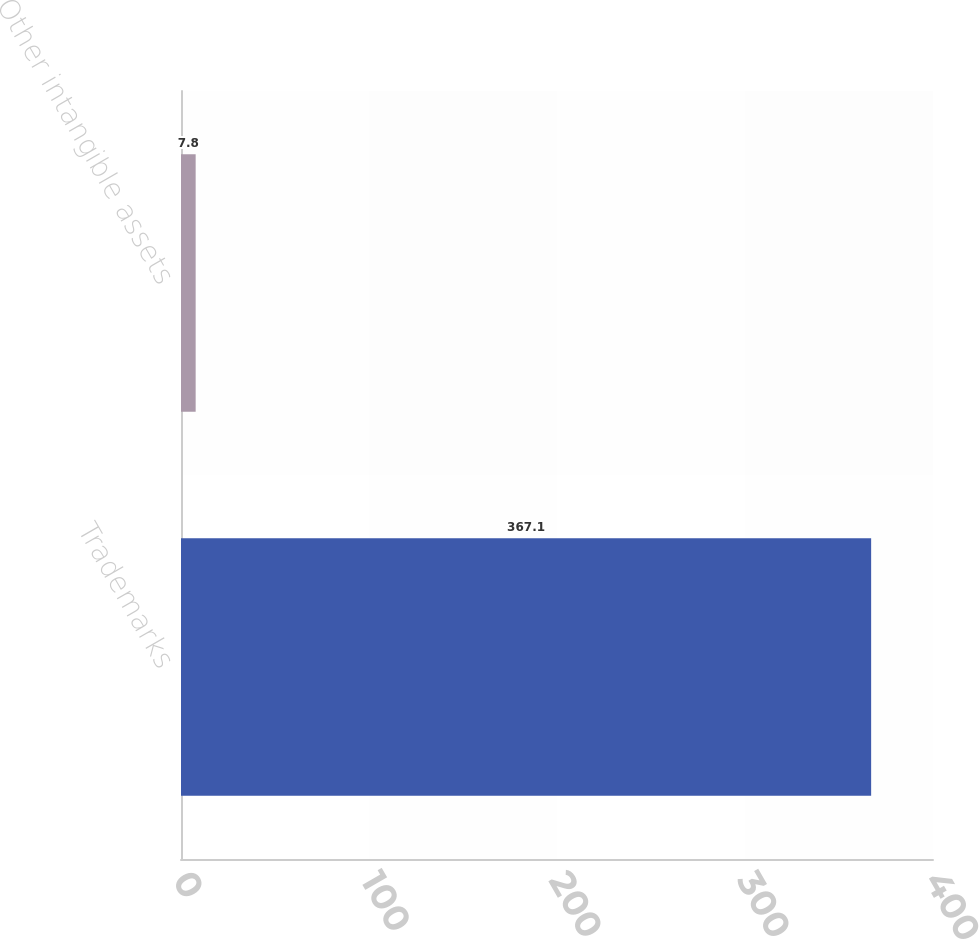Convert chart. <chart><loc_0><loc_0><loc_500><loc_500><bar_chart><fcel>Trademarks<fcel>Other intangible assets<nl><fcel>367.1<fcel>7.8<nl></chart> 